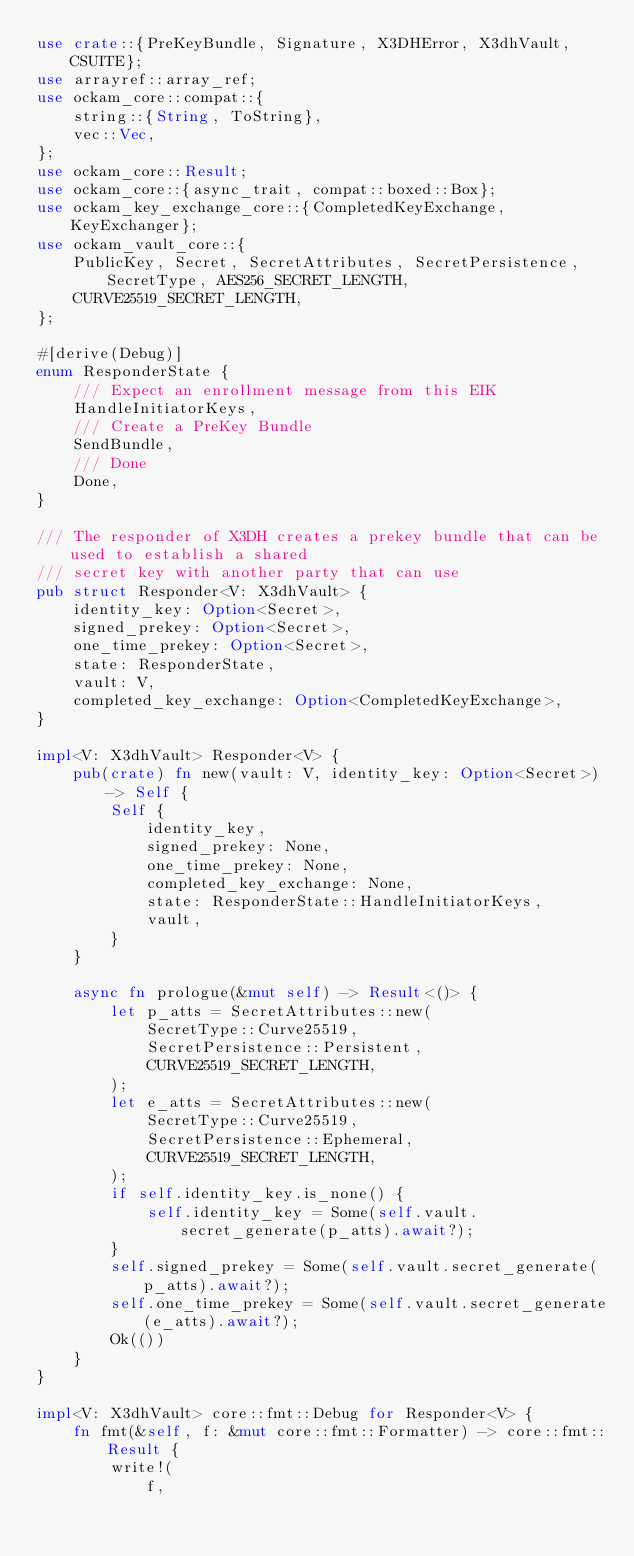<code> <loc_0><loc_0><loc_500><loc_500><_Rust_>use crate::{PreKeyBundle, Signature, X3DHError, X3dhVault, CSUITE};
use arrayref::array_ref;
use ockam_core::compat::{
    string::{String, ToString},
    vec::Vec,
};
use ockam_core::Result;
use ockam_core::{async_trait, compat::boxed::Box};
use ockam_key_exchange_core::{CompletedKeyExchange, KeyExchanger};
use ockam_vault_core::{
    PublicKey, Secret, SecretAttributes, SecretPersistence, SecretType, AES256_SECRET_LENGTH,
    CURVE25519_SECRET_LENGTH,
};

#[derive(Debug)]
enum ResponderState {
    /// Expect an enrollment message from this EIK
    HandleInitiatorKeys,
    /// Create a PreKey Bundle
    SendBundle,
    /// Done
    Done,
}

/// The responder of X3DH creates a prekey bundle that can be used to establish a shared
/// secret key with another party that can use
pub struct Responder<V: X3dhVault> {
    identity_key: Option<Secret>,
    signed_prekey: Option<Secret>,
    one_time_prekey: Option<Secret>,
    state: ResponderState,
    vault: V,
    completed_key_exchange: Option<CompletedKeyExchange>,
}

impl<V: X3dhVault> Responder<V> {
    pub(crate) fn new(vault: V, identity_key: Option<Secret>) -> Self {
        Self {
            identity_key,
            signed_prekey: None,
            one_time_prekey: None,
            completed_key_exchange: None,
            state: ResponderState::HandleInitiatorKeys,
            vault,
        }
    }

    async fn prologue(&mut self) -> Result<()> {
        let p_atts = SecretAttributes::new(
            SecretType::Curve25519,
            SecretPersistence::Persistent,
            CURVE25519_SECRET_LENGTH,
        );
        let e_atts = SecretAttributes::new(
            SecretType::Curve25519,
            SecretPersistence::Ephemeral,
            CURVE25519_SECRET_LENGTH,
        );
        if self.identity_key.is_none() {
            self.identity_key = Some(self.vault.secret_generate(p_atts).await?);
        }
        self.signed_prekey = Some(self.vault.secret_generate(p_atts).await?);
        self.one_time_prekey = Some(self.vault.secret_generate(e_atts).await?);
        Ok(())
    }
}

impl<V: X3dhVault> core::fmt::Debug for Responder<V> {
    fn fmt(&self, f: &mut core::fmt::Formatter) -> core::fmt::Result {
        write!(
            f,</code> 